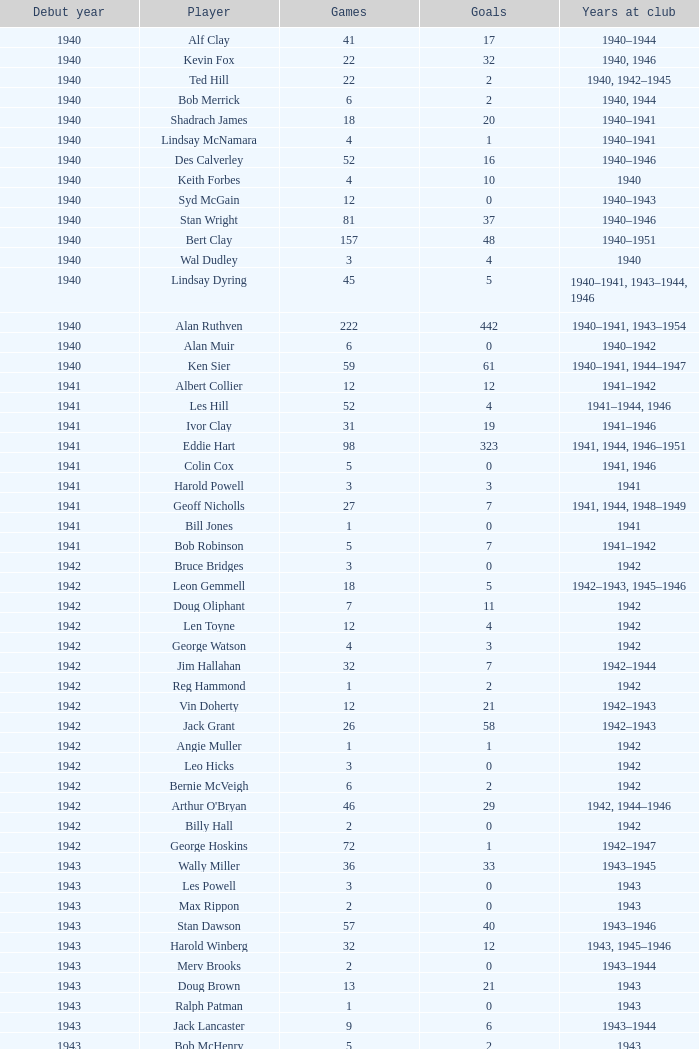Who is the player that began playing before 1943, was with the club in 1942, took part in less than 12 games, and registered a score of less than 11 goals? Bruce Bridges, George Watson, Reg Hammond, Angie Muller, Leo Hicks, Bernie McVeigh, Billy Hall. 